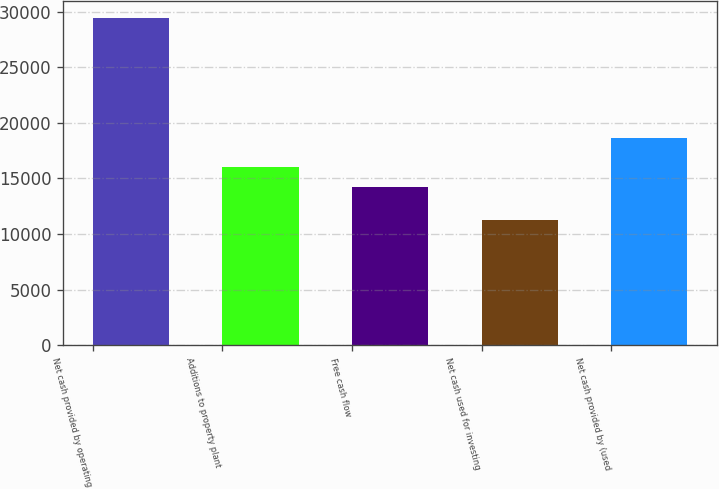Convert chart to OTSL. <chart><loc_0><loc_0><loc_500><loc_500><bar_chart><fcel>Net cash provided by operating<fcel>Additions to property plant<fcel>Free cash flow<fcel>Net cash used for investing<fcel>Net cash provided by (used<nl><fcel>29432<fcel>16070.3<fcel>14251<fcel>11239<fcel>18607<nl></chart> 